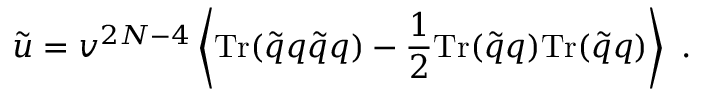<formula> <loc_0><loc_0><loc_500><loc_500>\tilde { u } = v ^ { 2 N - 4 } \left \langle T r ( \tilde { q } q \tilde { q } q ) - { \frac { 1 } { 2 } } T r ( \tilde { q } q ) T r ( \tilde { q } q ) \right \rangle \ .</formula> 